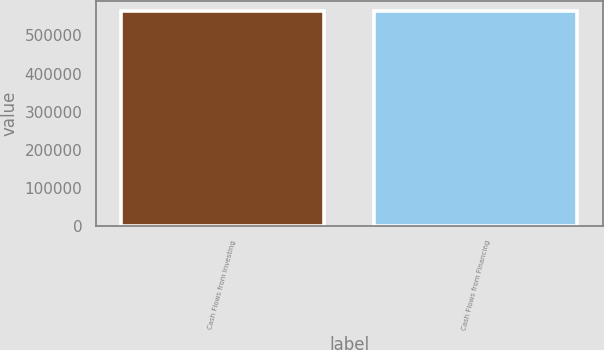<chart> <loc_0><loc_0><loc_500><loc_500><bar_chart><fcel>Cash Flows from Investing<fcel>Cash Flows from Financing<nl><fcel>562807<fcel>563166<nl></chart> 